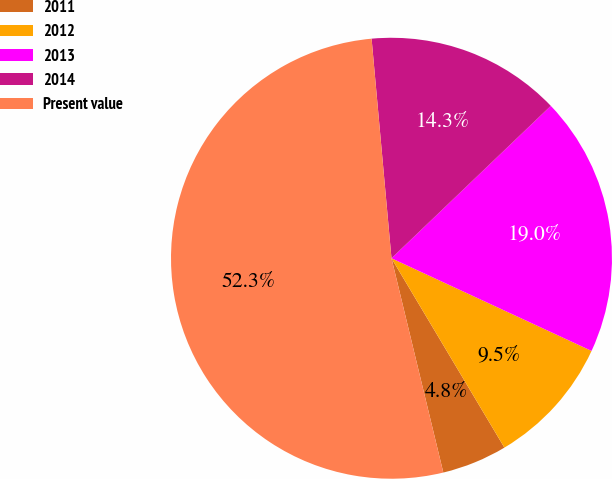Convert chart. <chart><loc_0><loc_0><loc_500><loc_500><pie_chart><fcel>2011<fcel>2012<fcel>2013<fcel>2014<fcel>Present value<nl><fcel>4.78%<fcel>9.54%<fcel>19.05%<fcel>14.29%<fcel>52.34%<nl></chart> 